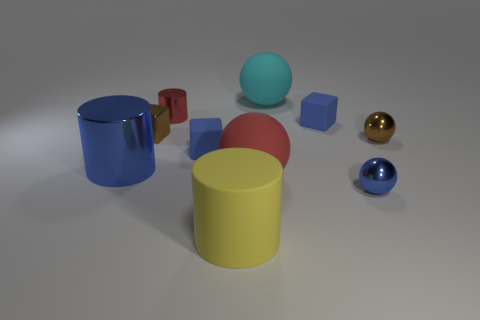Subtract all green spheres. Subtract all gray cubes. How many spheres are left? 4 Subtract all balls. How many objects are left? 6 Add 2 red cylinders. How many red cylinders are left? 3 Add 5 large cyan metallic cylinders. How many large cyan metallic cylinders exist? 5 Subtract 0 green balls. How many objects are left? 10 Subtract all small cylinders. Subtract all blue metal cylinders. How many objects are left? 8 